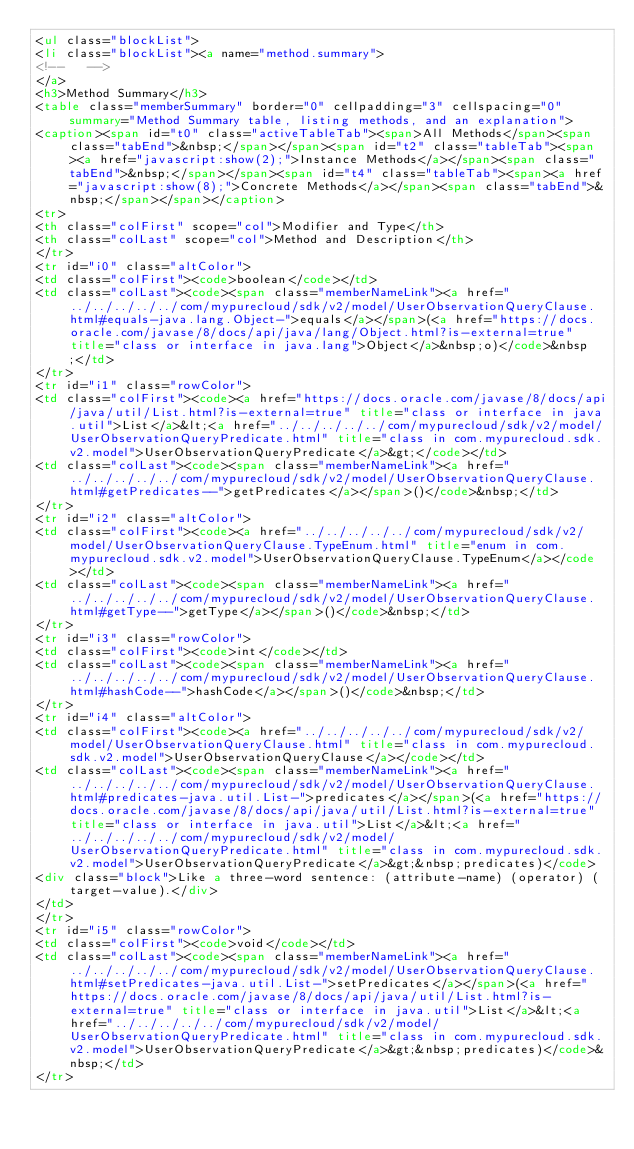<code> <loc_0><loc_0><loc_500><loc_500><_HTML_><ul class="blockList">
<li class="blockList"><a name="method.summary">
<!--   -->
</a>
<h3>Method Summary</h3>
<table class="memberSummary" border="0" cellpadding="3" cellspacing="0" summary="Method Summary table, listing methods, and an explanation">
<caption><span id="t0" class="activeTableTab"><span>All Methods</span><span class="tabEnd">&nbsp;</span></span><span id="t2" class="tableTab"><span><a href="javascript:show(2);">Instance Methods</a></span><span class="tabEnd">&nbsp;</span></span><span id="t4" class="tableTab"><span><a href="javascript:show(8);">Concrete Methods</a></span><span class="tabEnd">&nbsp;</span></span></caption>
<tr>
<th class="colFirst" scope="col">Modifier and Type</th>
<th class="colLast" scope="col">Method and Description</th>
</tr>
<tr id="i0" class="altColor">
<td class="colFirst"><code>boolean</code></td>
<td class="colLast"><code><span class="memberNameLink"><a href="../../../../../com/mypurecloud/sdk/v2/model/UserObservationQueryClause.html#equals-java.lang.Object-">equals</a></span>(<a href="https://docs.oracle.com/javase/8/docs/api/java/lang/Object.html?is-external=true" title="class or interface in java.lang">Object</a>&nbsp;o)</code>&nbsp;</td>
</tr>
<tr id="i1" class="rowColor">
<td class="colFirst"><code><a href="https://docs.oracle.com/javase/8/docs/api/java/util/List.html?is-external=true" title="class or interface in java.util">List</a>&lt;<a href="../../../../../com/mypurecloud/sdk/v2/model/UserObservationQueryPredicate.html" title="class in com.mypurecloud.sdk.v2.model">UserObservationQueryPredicate</a>&gt;</code></td>
<td class="colLast"><code><span class="memberNameLink"><a href="../../../../../com/mypurecloud/sdk/v2/model/UserObservationQueryClause.html#getPredicates--">getPredicates</a></span>()</code>&nbsp;</td>
</tr>
<tr id="i2" class="altColor">
<td class="colFirst"><code><a href="../../../../../com/mypurecloud/sdk/v2/model/UserObservationQueryClause.TypeEnum.html" title="enum in com.mypurecloud.sdk.v2.model">UserObservationQueryClause.TypeEnum</a></code></td>
<td class="colLast"><code><span class="memberNameLink"><a href="../../../../../com/mypurecloud/sdk/v2/model/UserObservationQueryClause.html#getType--">getType</a></span>()</code>&nbsp;</td>
</tr>
<tr id="i3" class="rowColor">
<td class="colFirst"><code>int</code></td>
<td class="colLast"><code><span class="memberNameLink"><a href="../../../../../com/mypurecloud/sdk/v2/model/UserObservationQueryClause.html#hashCode--">hashCode</a></span>()</code>&nbsp;</td>
</tr>
<tr id="i4" class="altColor">
<td class="colFirst"><code><a href="../../../../../com/mypurecloud/sdk/v2/model/UserObservationQueryClause.html" title="class in com.mypurecloud.sdk.v2.model">UserObservationQueryClause</a></code></td>
<td class="colLast"><code><span class="memberNameLink"><a href="../../../../../com/mypurecloud/sdk/v2/model/UserObservationQueryClause.html#predicates-java.util.List-">predicates</a></span>(<a href="https://docs.oracle.com/javase/8/docs/api/java/util/List.html?is-external=true" title="class or interface in java.util">List</a>&lt;<a href="../../../../../com/mypurecloud/sdk/v2/model/UserObservationQueryPredicate.html" title="class in com.mypurecloud.sdk.v2.model">UserObservationQueryPredicate</a>&gt;&nbsp;predicates)</code>
<div class="block">Like a three-word sentence: (attribute-name) (operator) (target-value).</div>
</td>
</tr>
<tr id="i5" class="rowColor">
<td class="colFirst"><code>void</code></td>
<td class="colLast"><code><span class="memberNameLink"><a href="../../../../../com/mypurecloud/sdk/v2/model/UserObservationQueryClause.html#setPredicates-java.util.List-">setPredicates</a></span>(<a href="https://docs.oracle.com/javase/8/docs/api/java/util/List.html?is-external=true" title="class or interface in java.util">List</a>&lt;<a href="../../../../../com/mypurecloud/sdk/v2/model/UserObservationQueryPredicate.html" title="class in com.mypurecloud.sdk.v2.model">UserObservationQueryPredicate</a>&gt;&nbsp;predicates)</code>&nbsp;</td>
</tr></code> 